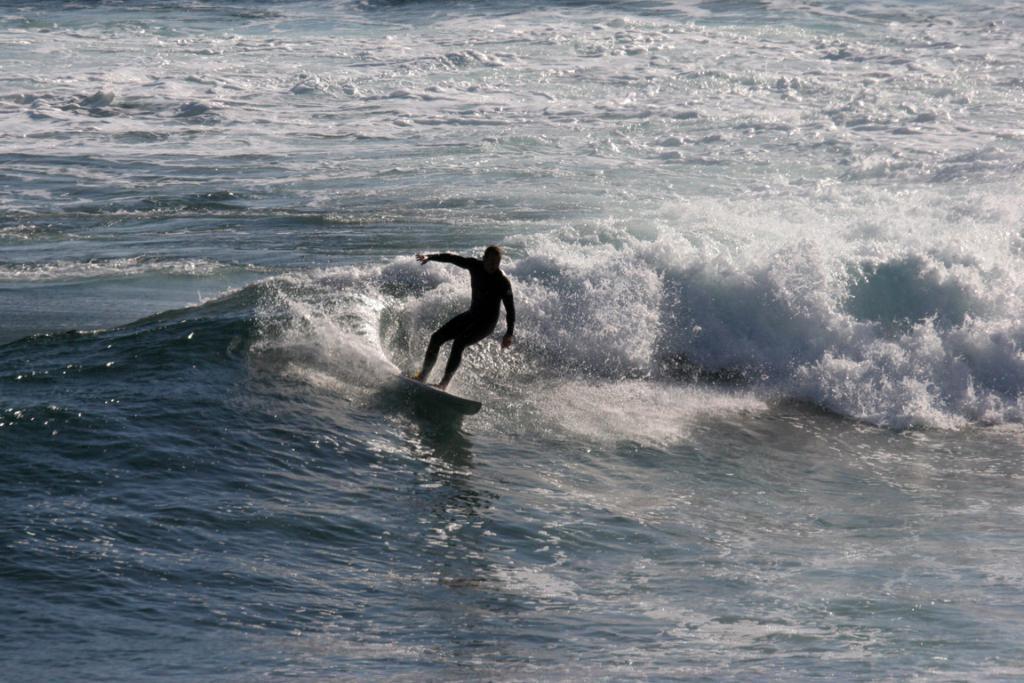Could you give a brief overview of what you see in this image? In this image I can see water and on it I can see a person is standing on a surfing board. 